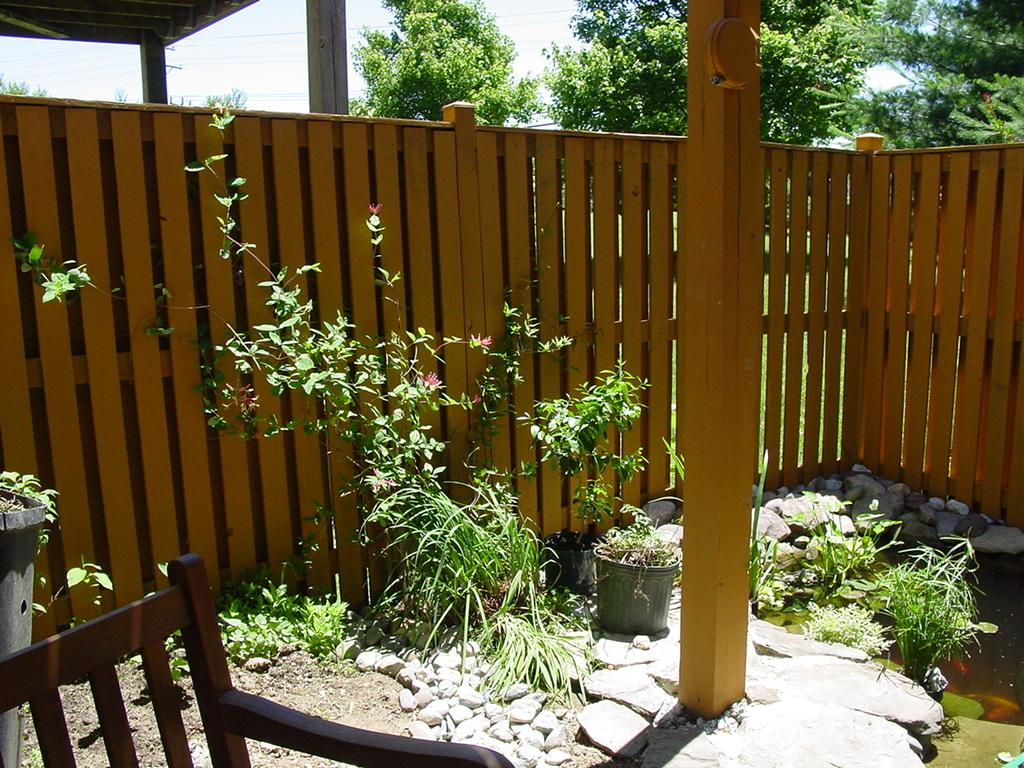What type of furniture is present in the image? There is a chair in the image. What is located behind the chair? There are stones behind the chair. What other objects or features can be seen in the image? There are plants, wooden fencing, and many trees in the background of the image. Can you see any apples being bitten by someone in jail in the image? There is no jail, person, or apple present in the image. 